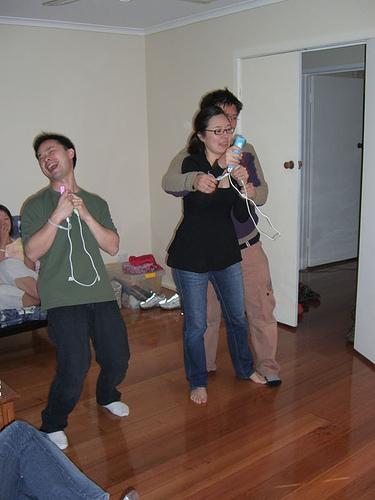What is the person not engaged in conversation doing?
Write a very short answer. Laughing. Is the woman wearing shoes?
Write a very short answer. No. What are the children standing on?
Give a very brief answer. Floor. How many people are there?
Concise answer only. 5. What race are the people in the image?
Answer briefly. Asian. 